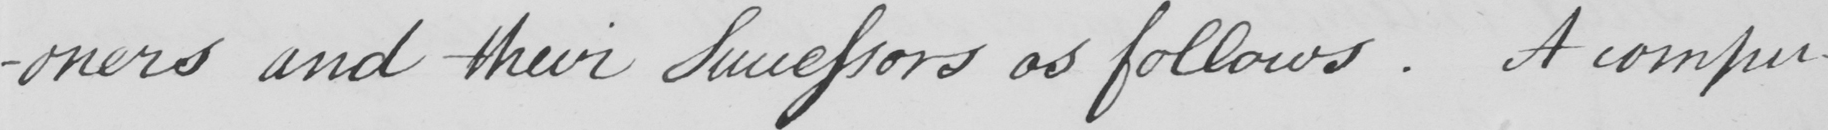Can you read and transcribe this handwriting? -oners and their Successors as follows . A compu- 